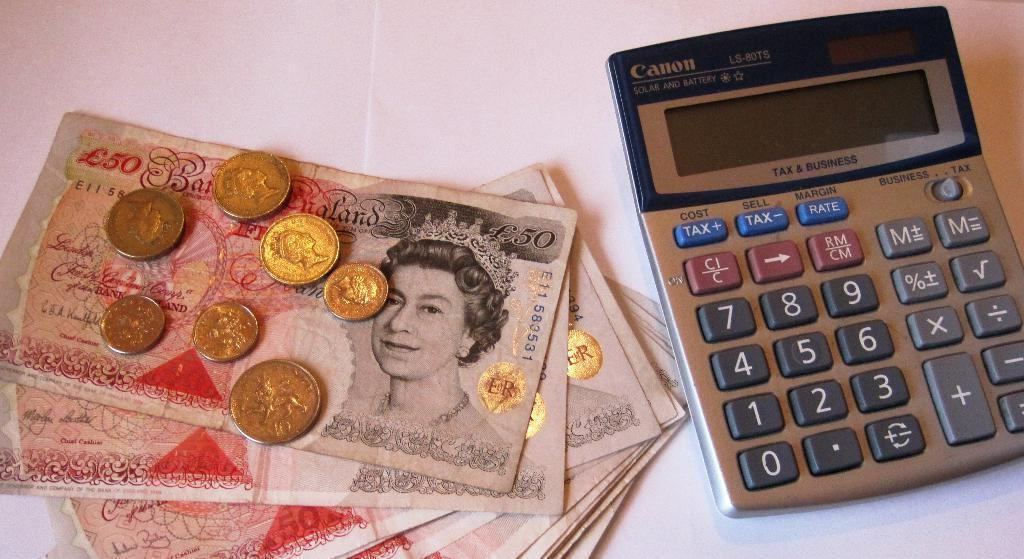<image>
Render a clear and concise summary of the photo. A Canon calculator that says tax and business on it laying next to a pile of foreign money. 